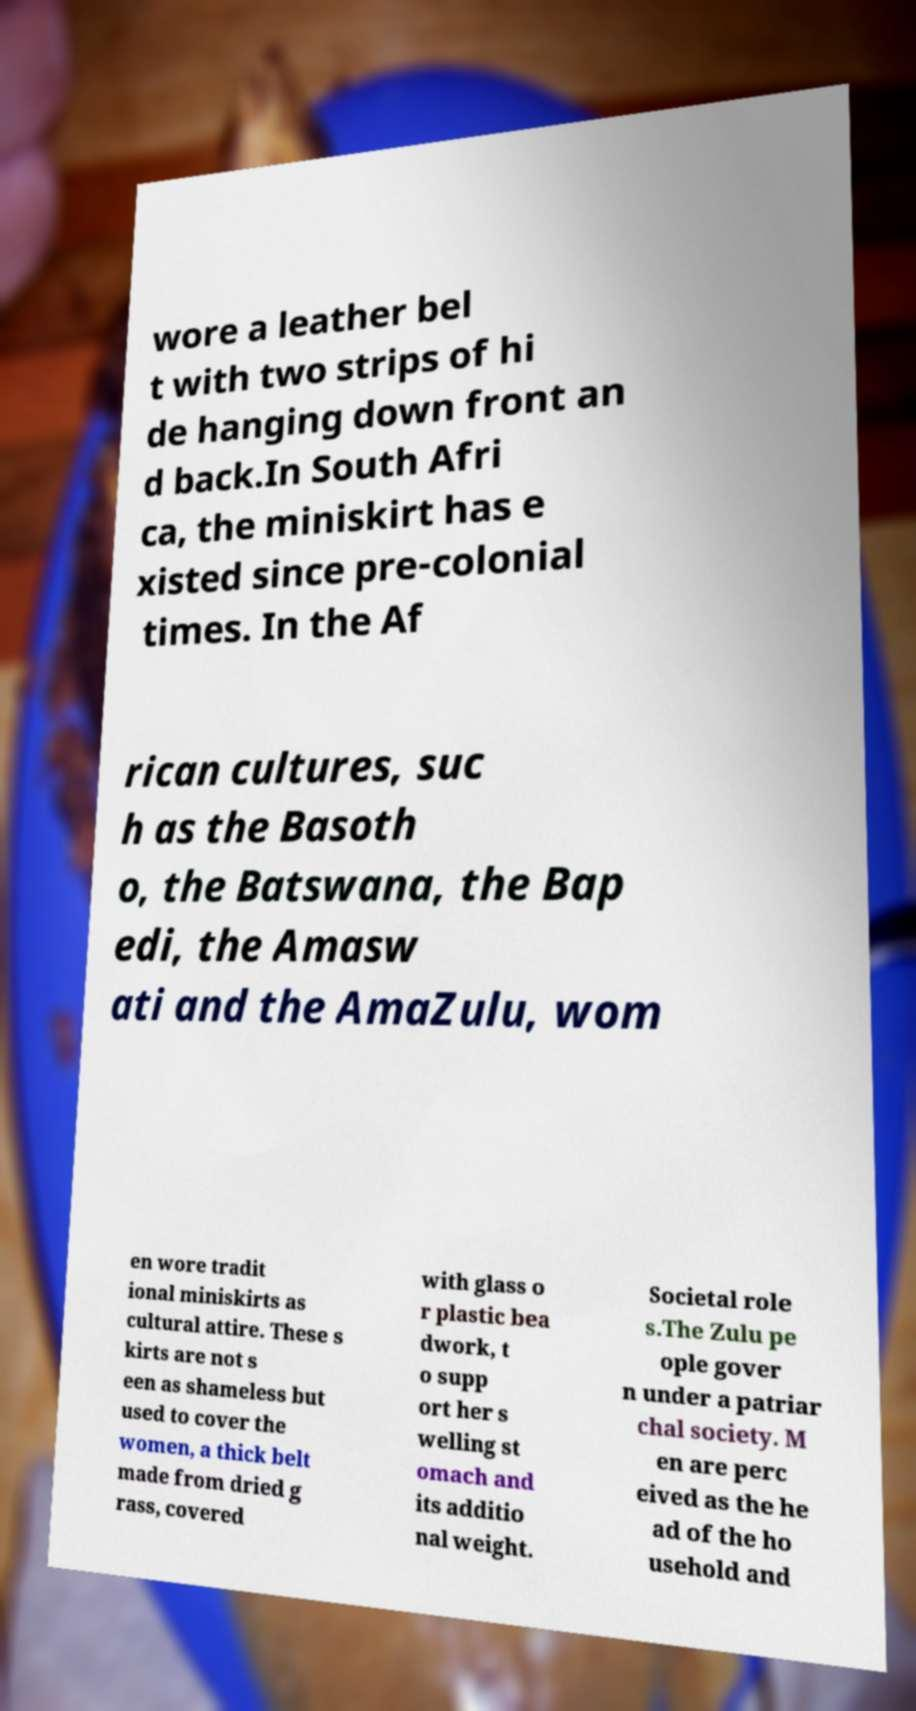I need the written content from this picture converted into text. Can you do that? wore a leather bel t with two strips of hi de hanging down front an d back.In South Afri ca, the miniskirt has e xisted since pre-colonial times. In the Af rican cultures, suc h as the Basoth o, the Batswana, the Bap edi, the Amasw ati and the AmaZulu, wom en wore tradit ional miniskirts as cultural attire. These s kirts are not s een as shameless but used to cover the women, a thick belt made from dried g rass, covered with glass o r plastic bea dwork, t o supp ort her s welling st omach and its additio nal weight. Societal role s.The Zulu pe ople gover n under a patriar chal society. M en are perc eived as the he ad of the ho usehold and 